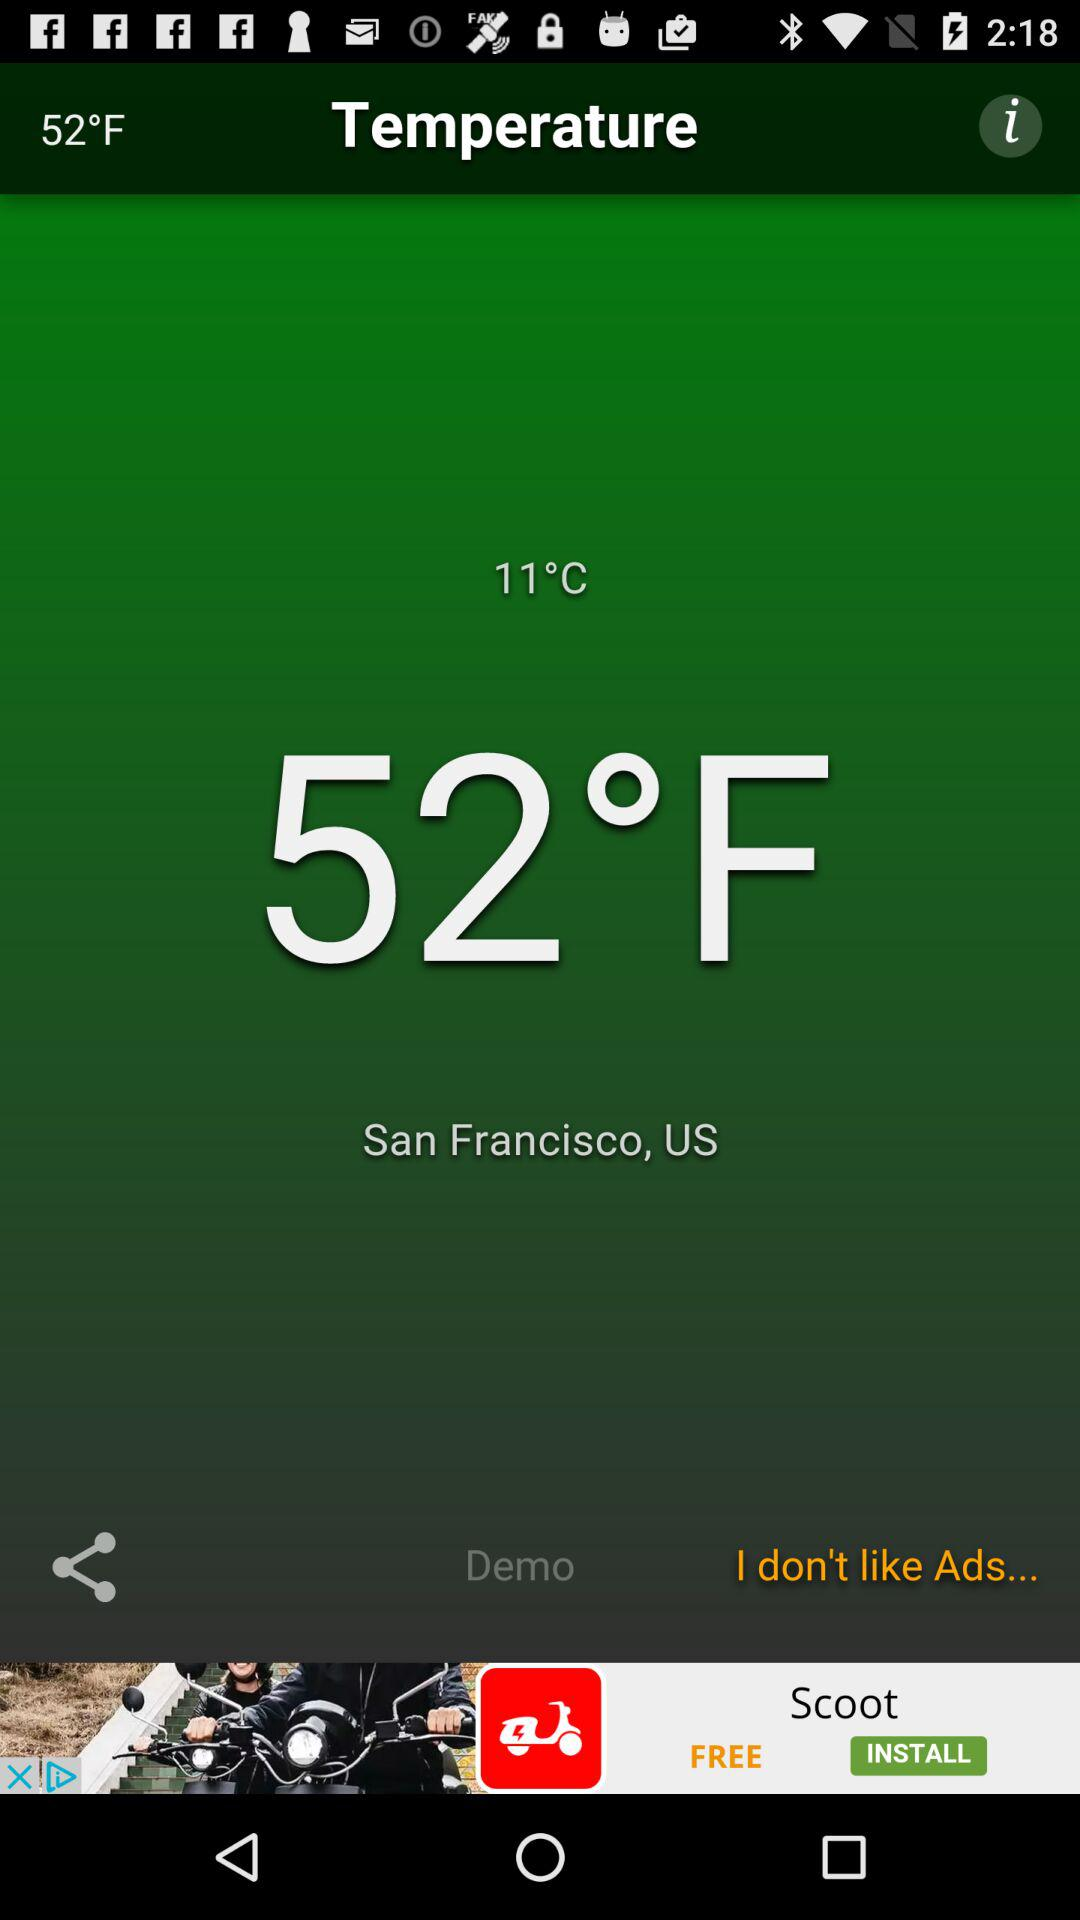What is the difference between the temperature in degrees Fahrenheit and degrees Celsius?
Answer the question using a single word or phrase. 41 